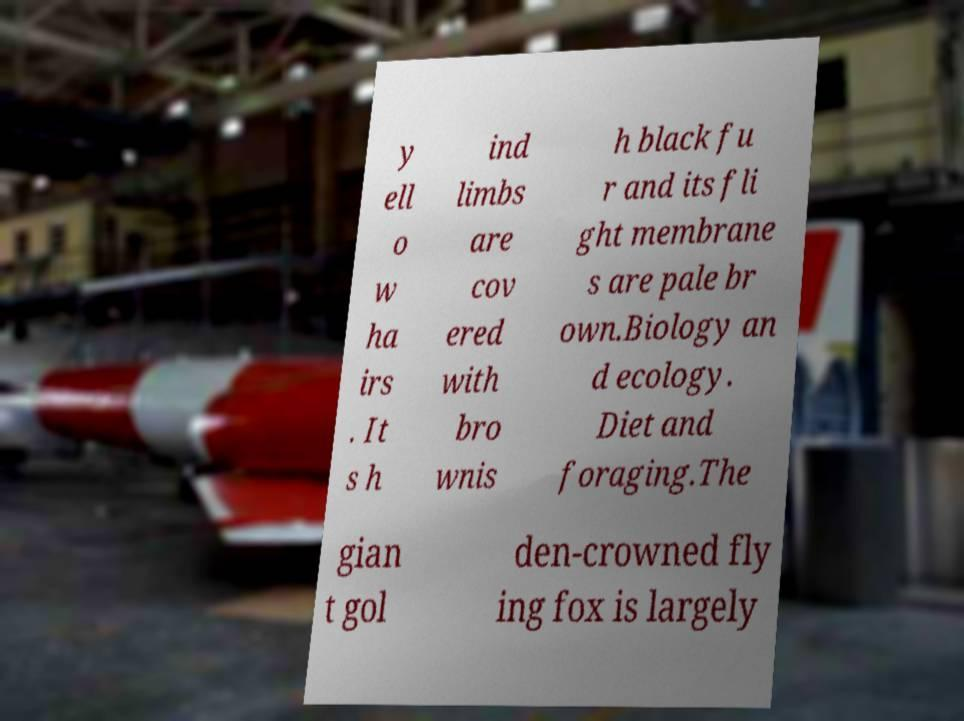Please read and relay the text visible in this image. What does it say? y ell o w ha irs . It s h ind limbs are cov ered with bro wnis h black fu r and its fli ght membrane s are pale br own.Biology an d ecology. Diet and foraging.The gian t gol den-crowned fly ing fox is largely 